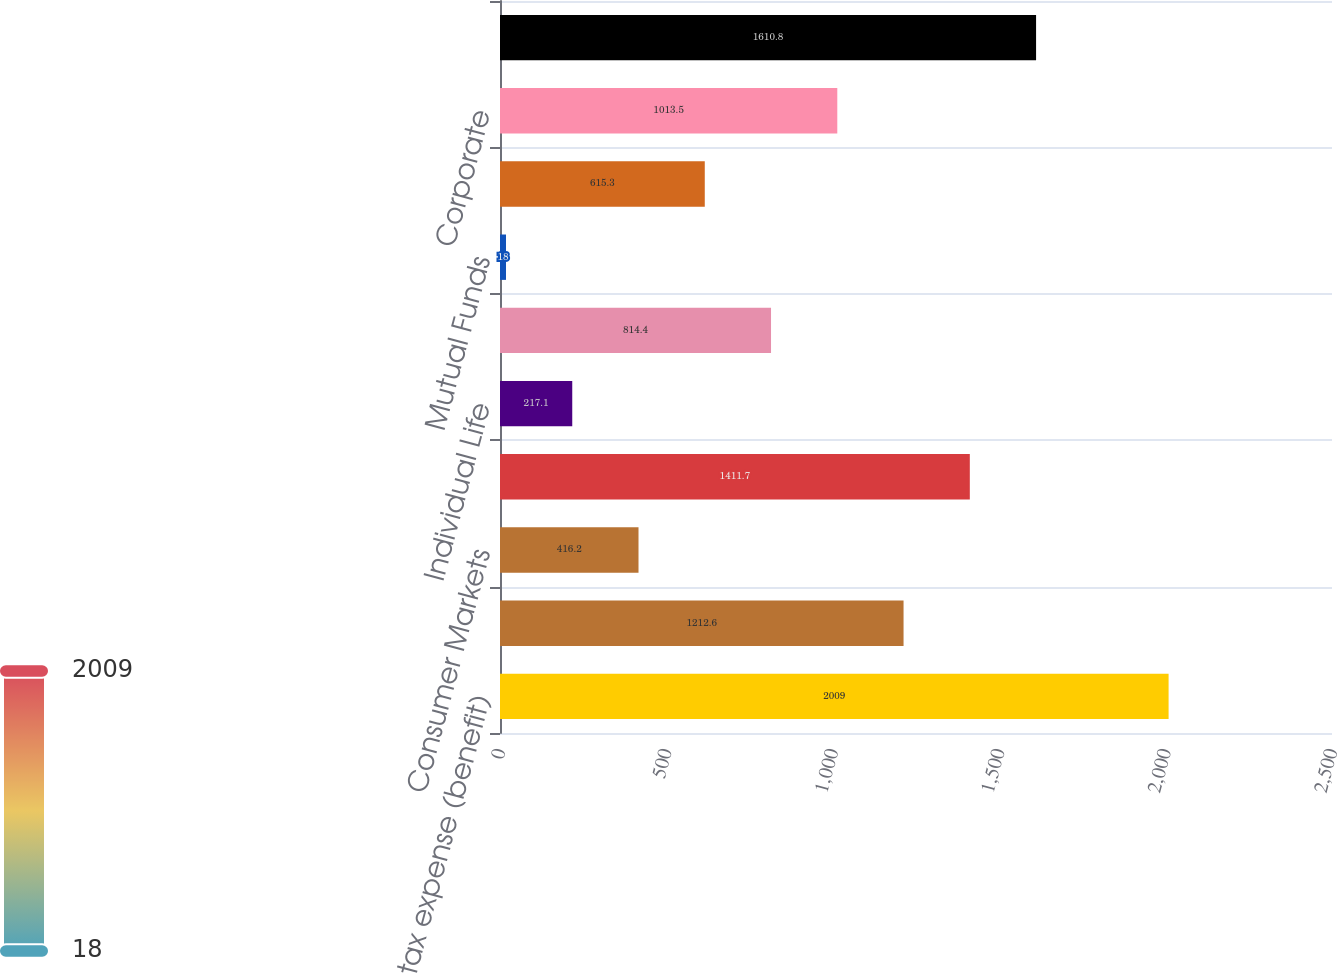Convert chart. <chart><loc_0><loc_0><loc_500><loc_500><bar_chart><fcel>Income tax expense (benefit)<fcel>Property & Casualty Commercial<fcel>Consumer Markets<fcel>Individual Annuity<fcel>Individual Life<fcel>Retirement Plans<fcel>Mutual Funds<fcel>Property & Casualty Other<fcel>Corporate<fcel>Total income tax expense<nl><fcel>2009<fcel>1212.6<fcel>416.2<fcel>1411.7<fcel>217.1<fcel>814.4<fcel>18<fcel>615.3<fcel>1013.5<fcel>1610.8<nl></chart> 